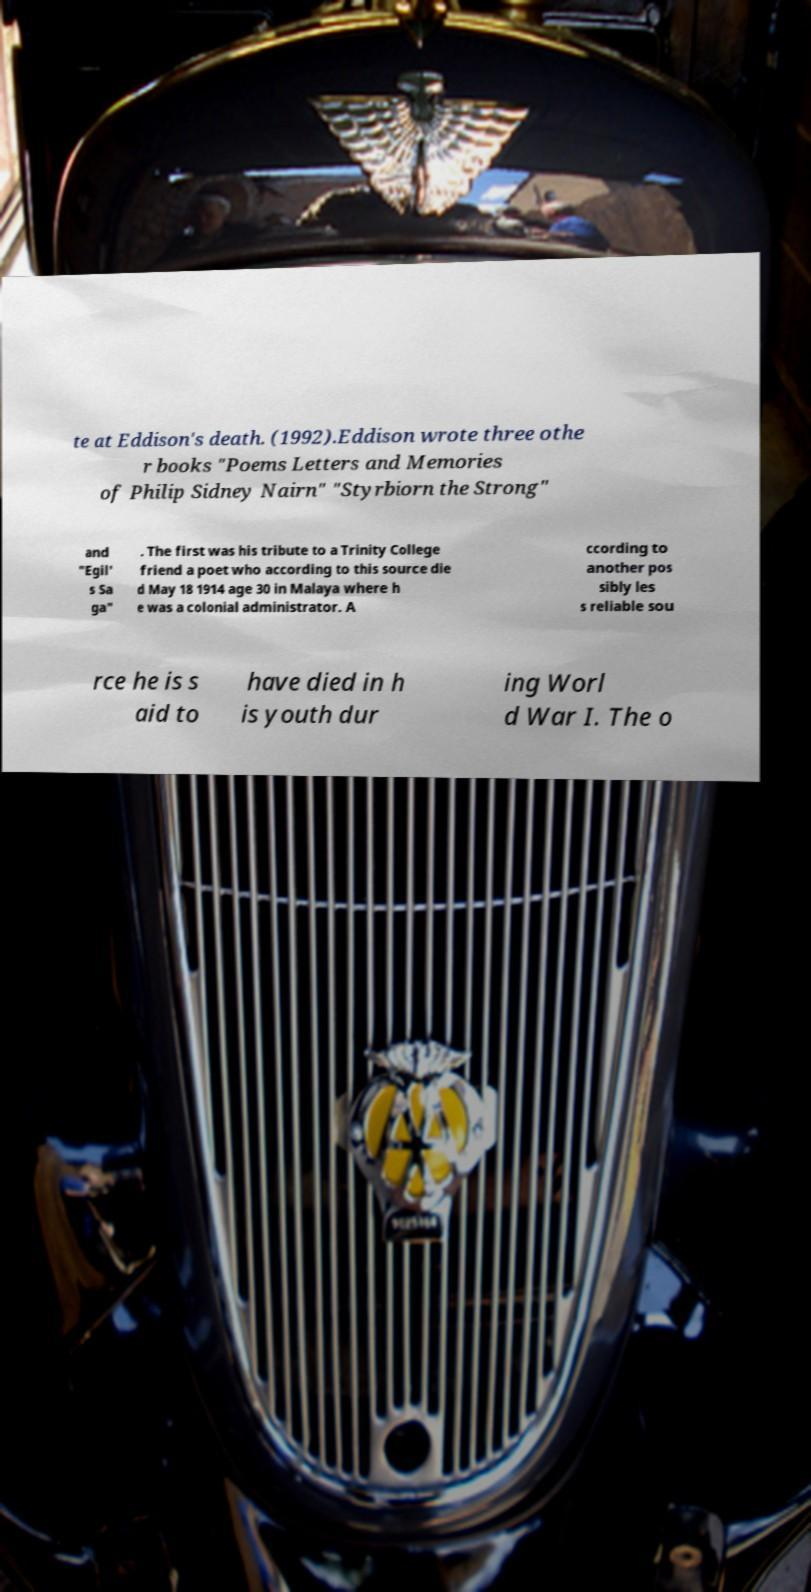Could you assist in decoding the text presented in this image and type it out clearly? te at Eddison's death. (1992).Eddison wrote three othe r books "Poems Letters and Memories of Philip Sidney Nairn" "Styrbiorn the Strong" and "Egil' s Sa ga" . The first was his tribute to a Trinity College friend a poet who according to this source die d May 18 1914 age 30 in Malaya where h e was a colonial administrator. A ccording to another pos sibly les s reliable sou rce he is s aid to have died in h is youth dur ing Worl d War I. The o 